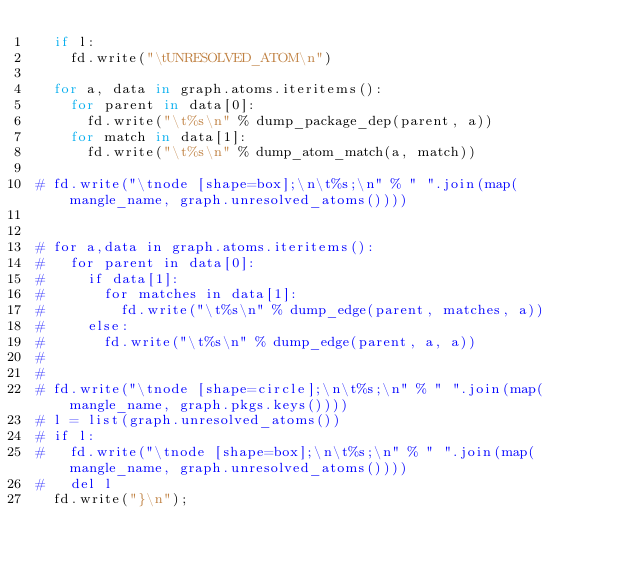Convert code to text. <code><loc_0><loc_0><loc_500><loc_500><_Python_>	if l:
		fd.write("\tUNRESOLVED_ATOM\n")

	for a, data in graph.atoms.iteritems():
		for parent in data[0]:
			fd.write("\t%s\n" % dump_package_dep(parent, a))
		for match in data[1]:
			fd.write("\t%s\n" % dump_atom_match(a, match))

#	fd.write("\tnode [shape=box];\n\t%s;\n" % " ".join(map(mangle_name, graph.unresolved_atoms())))


#	for a,data in graph.atoms.iteritems():
#		for parent in data[0]:
#			if data[1]:
#				for matches in data[1]:
#					fd.write("\t%s\n" % dump_edge(parent, matches, a))
#			else:
#				fd.write("\t%s\n" % dump_edge(parent, a, a))
#
#
#	fd.write("\tnode [shape=circle];\n\t%s;\n" % " ".join(map(mangle_name, graph.pkgs.keys())))
#	l = list(graph.unresolved_atoms())
#	if l:
#		fd.write("\tnode [shape=box];\n\t%s;\n" % " ".join(map(mangle_name, graph.unresolved_atoms())))
#		del l
	fd.write("}\n");

</code> 